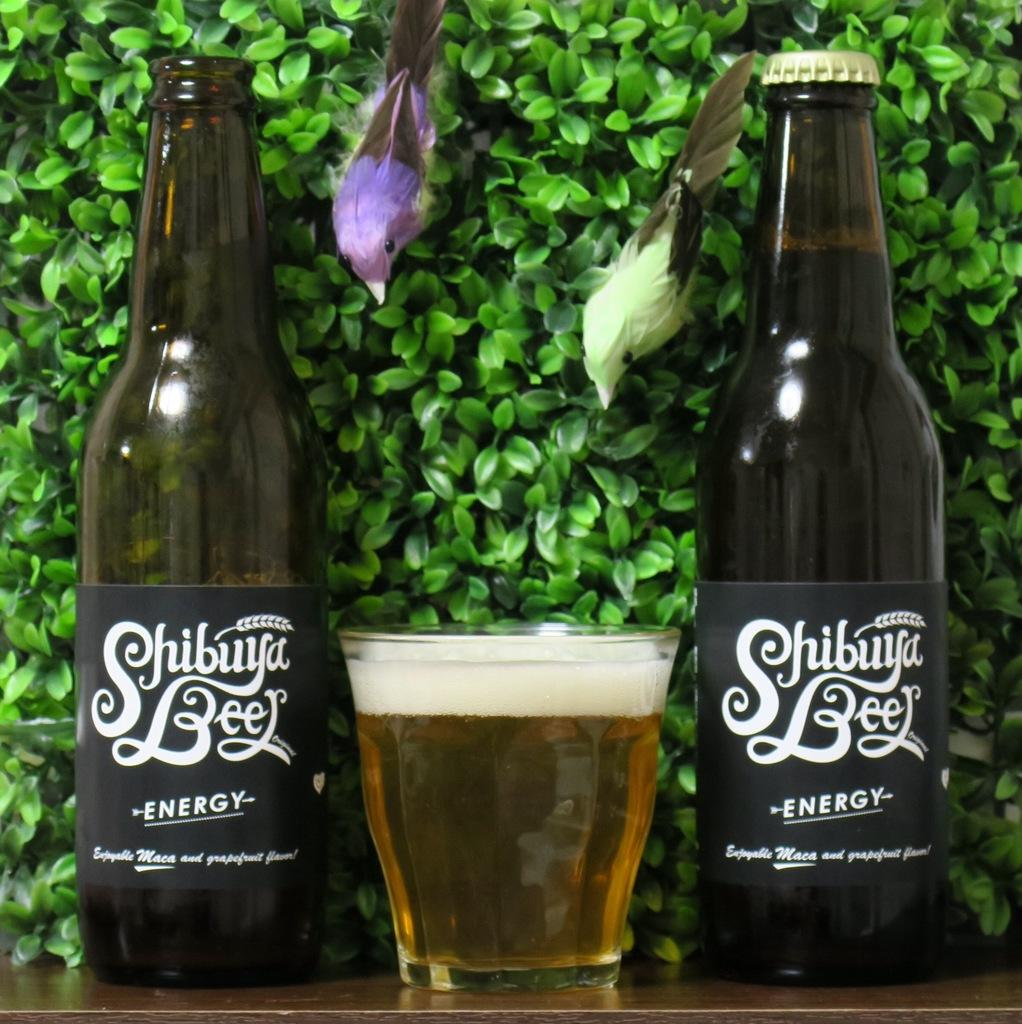<image>
Relay a brief, clear account of the picture shown. Two bottles have the word energy on them and a glass between them. 